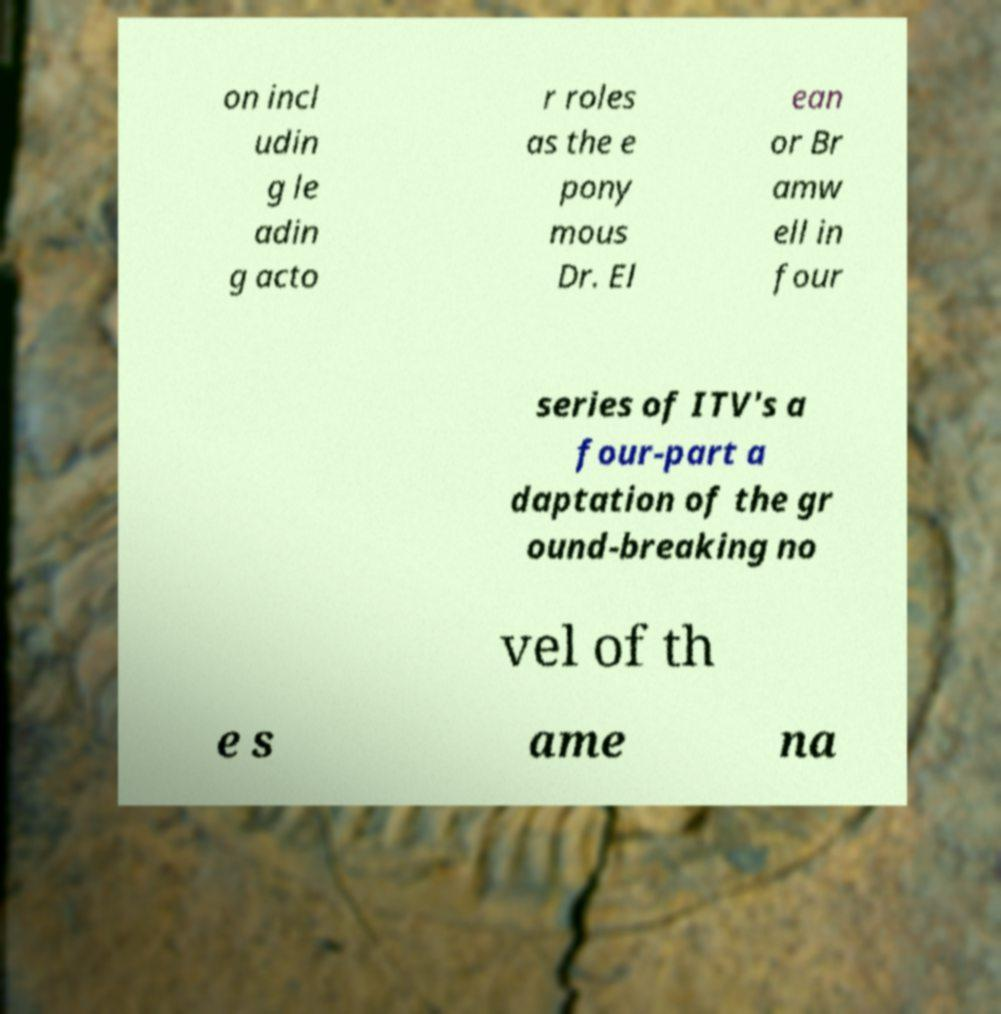Please read and relay the text visible in this image. What does it say? on incl udin g le adin g acto r roles as the e pony mous Dr. El ean or Br amw ell in four series of ITV's a four-part a daptation of the gr ound-breaking no vel of th e s ame na 